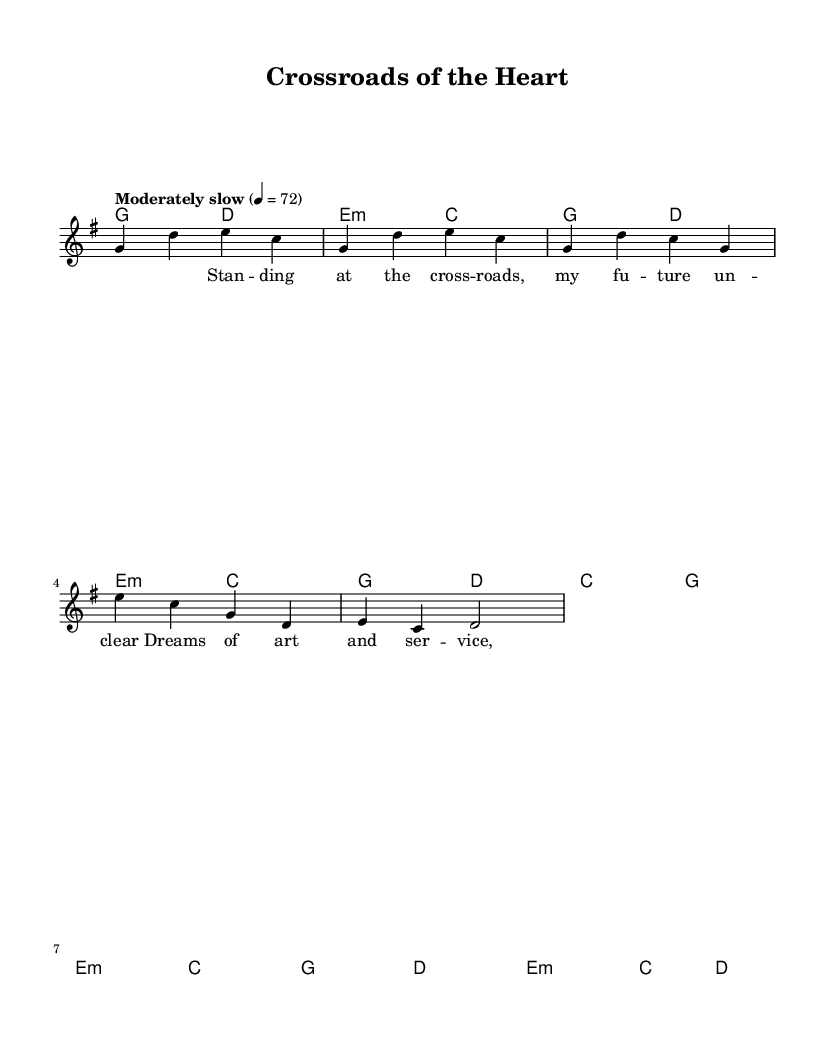What is the key signature of this music? The key signature is G major, which has one sharp (F#). This can be identified in the global context section where the key is defined.
Answer: G major What is the time signature of this music? The time signature is 4/4, indicating that there are four beats in each measure and the quarter note gets one beat. This is also defined in the global section of the code.
Answer: 4/4 What is the tempo marking of this piece? The tempo marking is "Moderately slow" at a metronome marking of quarter note equals 72. This is found in the global section under the tempo directive.
Answer: Moderately slow How many measures are in the intro section? The intro section consists of two measures: g2 d2 and e2:m c2, as specified in the harmonies part of the score.
Answer: 2 Which chord follows the first measure of the verse? The chord that follows the first measure of the verse is D major. In the harmonies, you can see the sequence where D chords come after G chords for the verse section.
Answer: D What lyrical theme is predominantly explored in the song? The lyrics explore themes of personal growth and decision-making, as indicated by phrases like "standing at the crossroads" and "future unclear." This reflects a common indie folk motif regarding choices and self-discovery.
Answer: Personal growth and decision-making What is the last chord in the chorus? The last chord in the chorus is D. This can be counted by looking at the last line of harmonies where it concludes with e2:m c4 d4.
Answer: D 